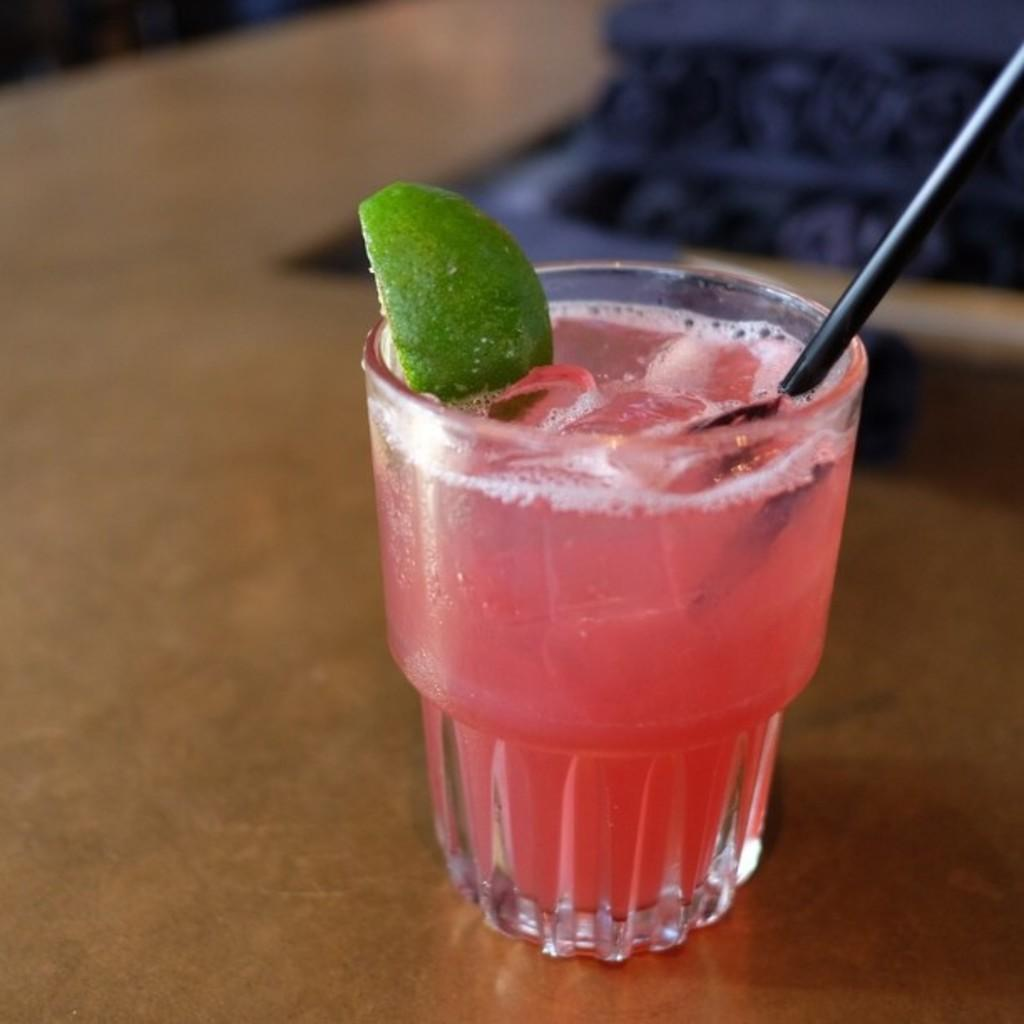What is in the glass that is visible in the image? There is a drink in the glass in the image. What additional item can be seen in the drink? There is a piece of lemon in the image. How might someone consume the drink in the image? A straw is present in the image, which could be used to drink the beverage. Can you describe the quality of the image? The image is slightly blurred. Reasoning: Let'g: Let's think step by step in order to produce the conversation. We start by identifying the main subject in the image, which is the glass with a drink. Then, we expand the conversation to include other items that are also visible, such as the piece of lemon and the straw. We also mention the quality of the image, which is slightly blurred. Each question is designed to elicit a specific detail about the image that is known from the provided facts. Absurd Question/Answer: What type of prose is being written on the glass in the image? There is no prose or writing visible on the glass in the image; it contains a drink with a piece of lemon and a straw. What type of beam is holding up the glass in the image? There is no beam present in the image; the glass is likely resting on a table or other surface. 